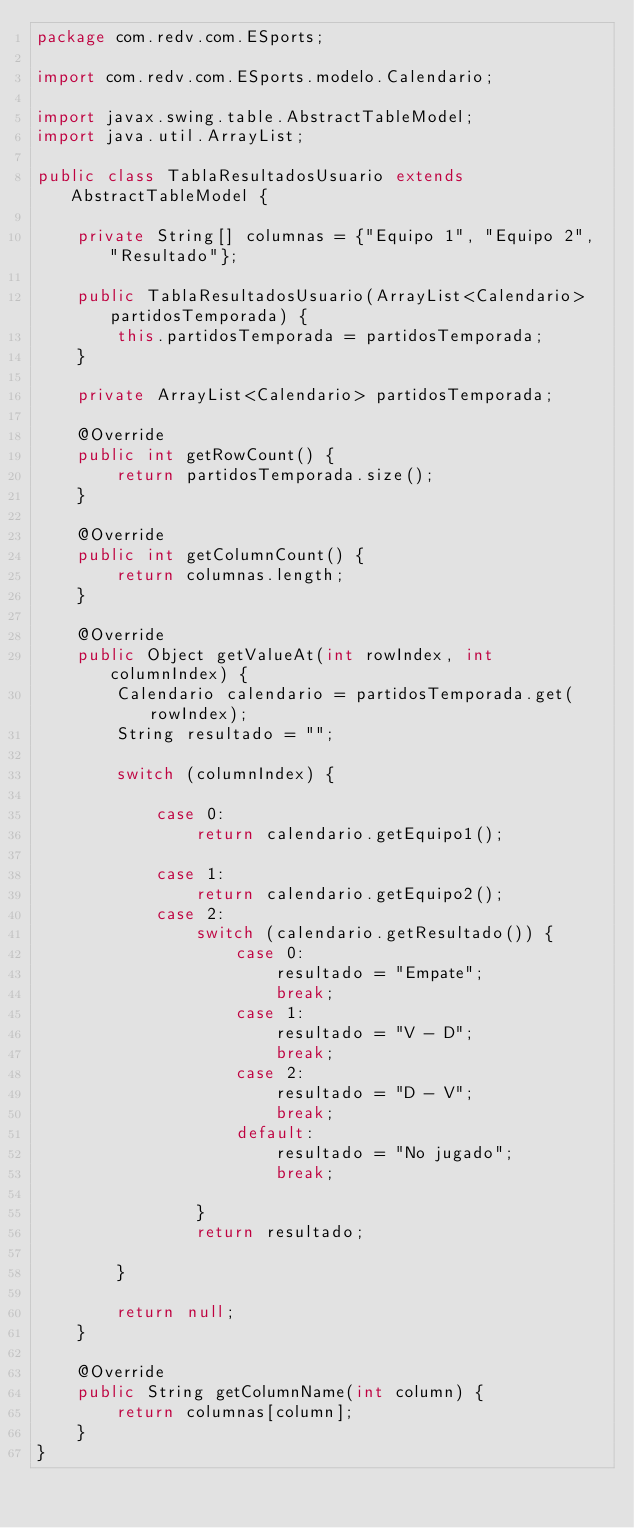<code> <loc_0><loc_0><loc_500><loc_500><_Java_>package com.redv.com.ESports;

import com.redv.com.ESports.modelo.Calendario;

import javax.swing.table.AbstractTableModel;
import java.util.ArrayList;

public class TablaResultadosUsuario extends AbstractTableModel {

    private String[] columnas = {"Equipo 1", "Equipo 2", "Resultado"};

    public TablaResultadosUsuario(ArrayList<Calendario> partidosTemporada) {
        this.partidosTemporada = partidosTemporada;
    }

    private ArrayList<Calendario> partidosTemporada;

    @Override
    public int getRowCount() {
        return partidosTemporada.size();
    }

    @Override
    public int getColumnCount() {
        return columnas.length;
    }

    @Override
    public Object getValueAt(int rowIndex, int columnIndex) {
        Calendario calendario = partidosTemporada.get(rowIndex);
        String resultado = "";

        switch (columnIndex) {

            case 0:
                return calendario.getEquipo1();

            case 1:
                return calendario.getEquipo2();
            case 2:
                switch (calendario.getResultado()) {
                    case 0:
                        resultado = "Empate";
                        break;
                    case 1:
                        resultado = "V - D";
                        break;
                    case 2:
                        resultado = "D - V";
                        break;
                    default:
                        resultado = "No jugado";
                        break;

                }
                return resultado;

        }

        return null;
    }

    @Override
    public String getColumnName(int column) {
        return columnas[column];
    }
}
</code> 